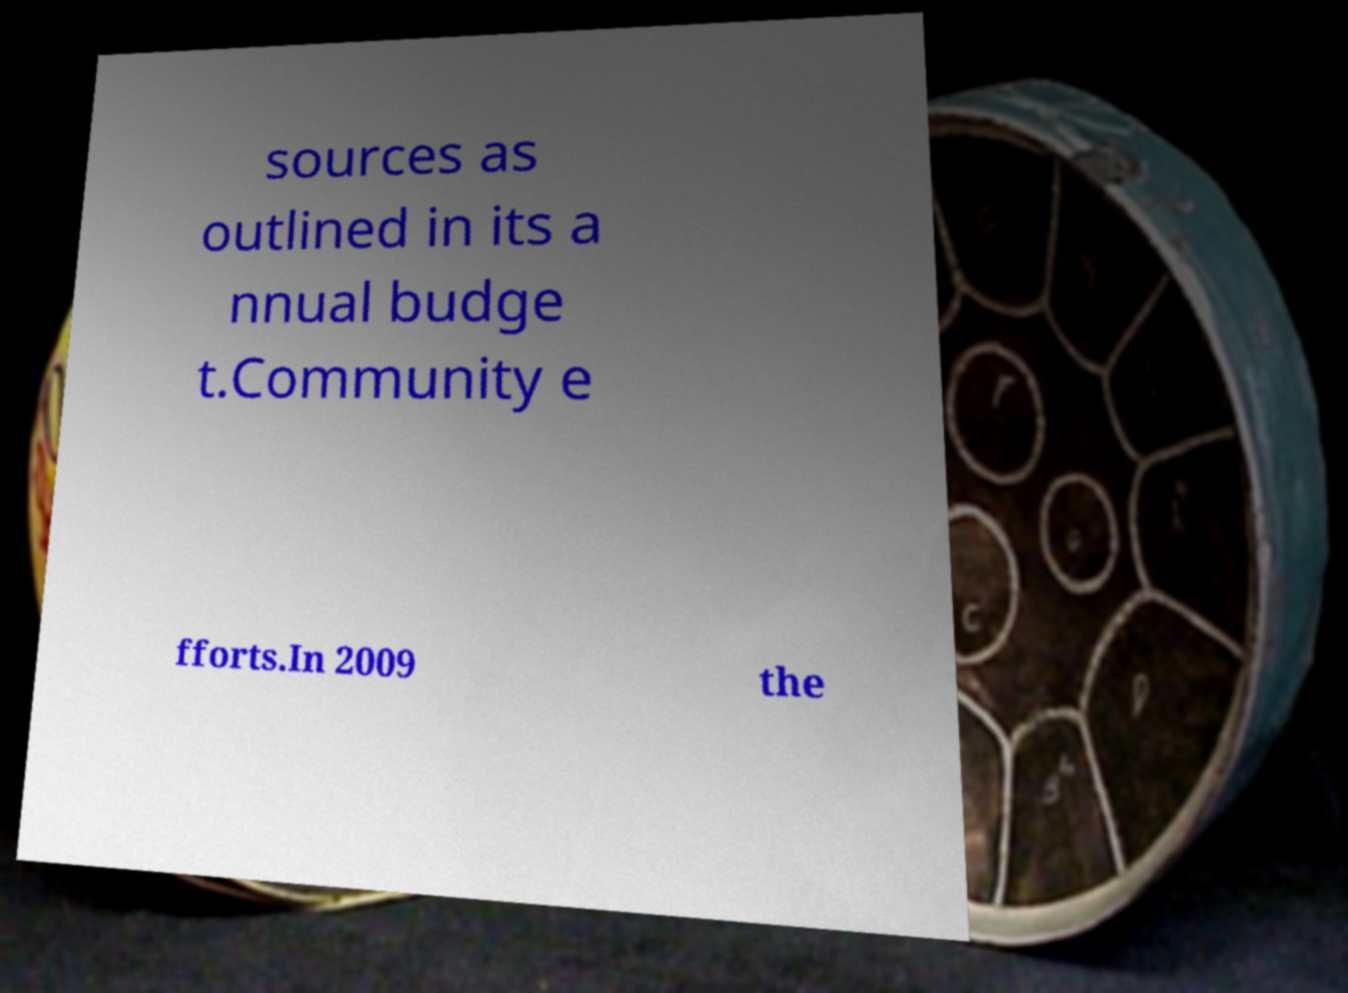Please identify and transcribe the text found in this image. sources as outlined in its a nnual budge t.Community e fforts.In 2009 the 